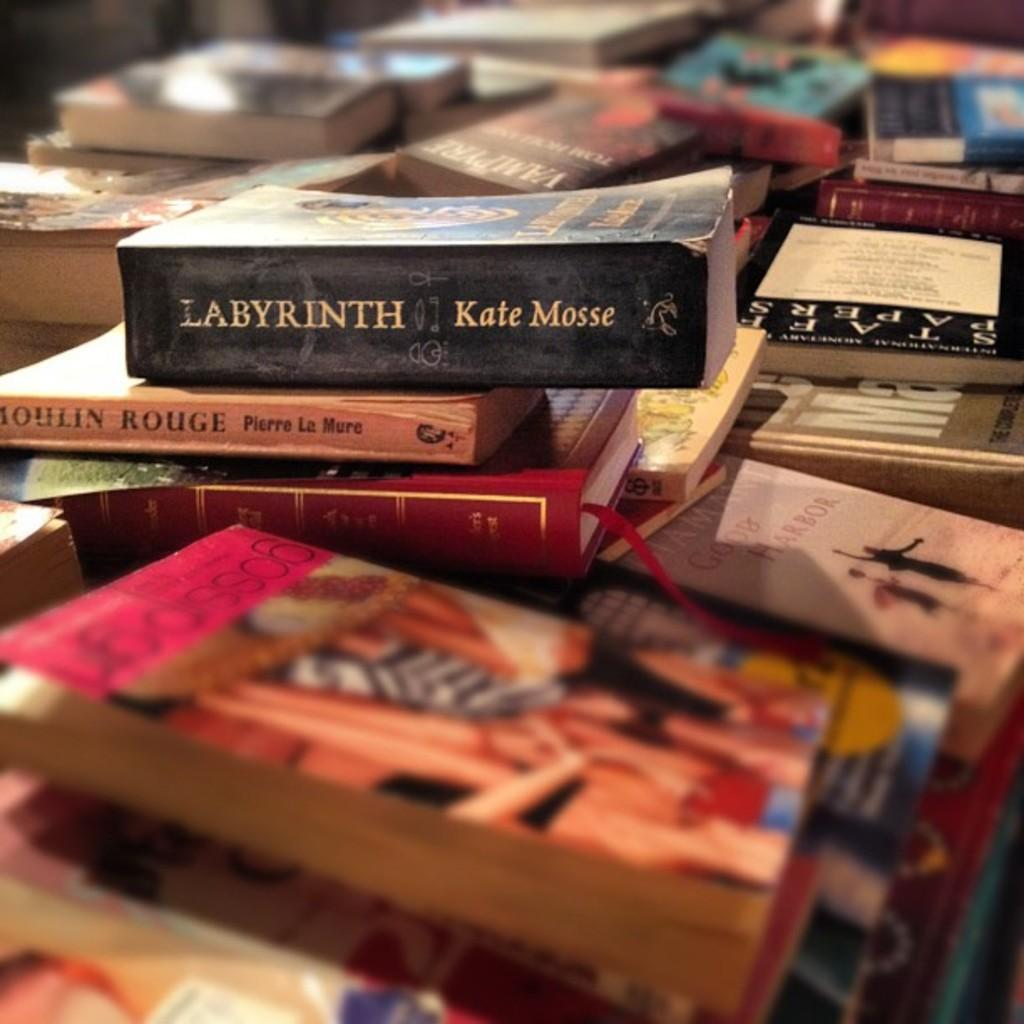<image>
Create a compact narrative representing the image presented. The top book in the pile is Labyrinth by Kate Mosse 